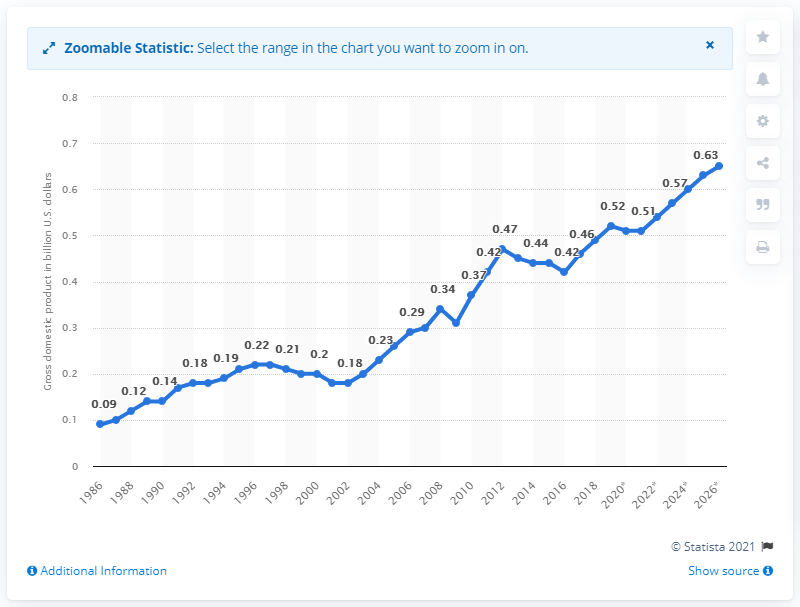Identify some key points in this picture. According to the latest estimates, Tonga's Gross Domestic Product (GDP) in 2019 was approximately 0.52 billion dollars. 